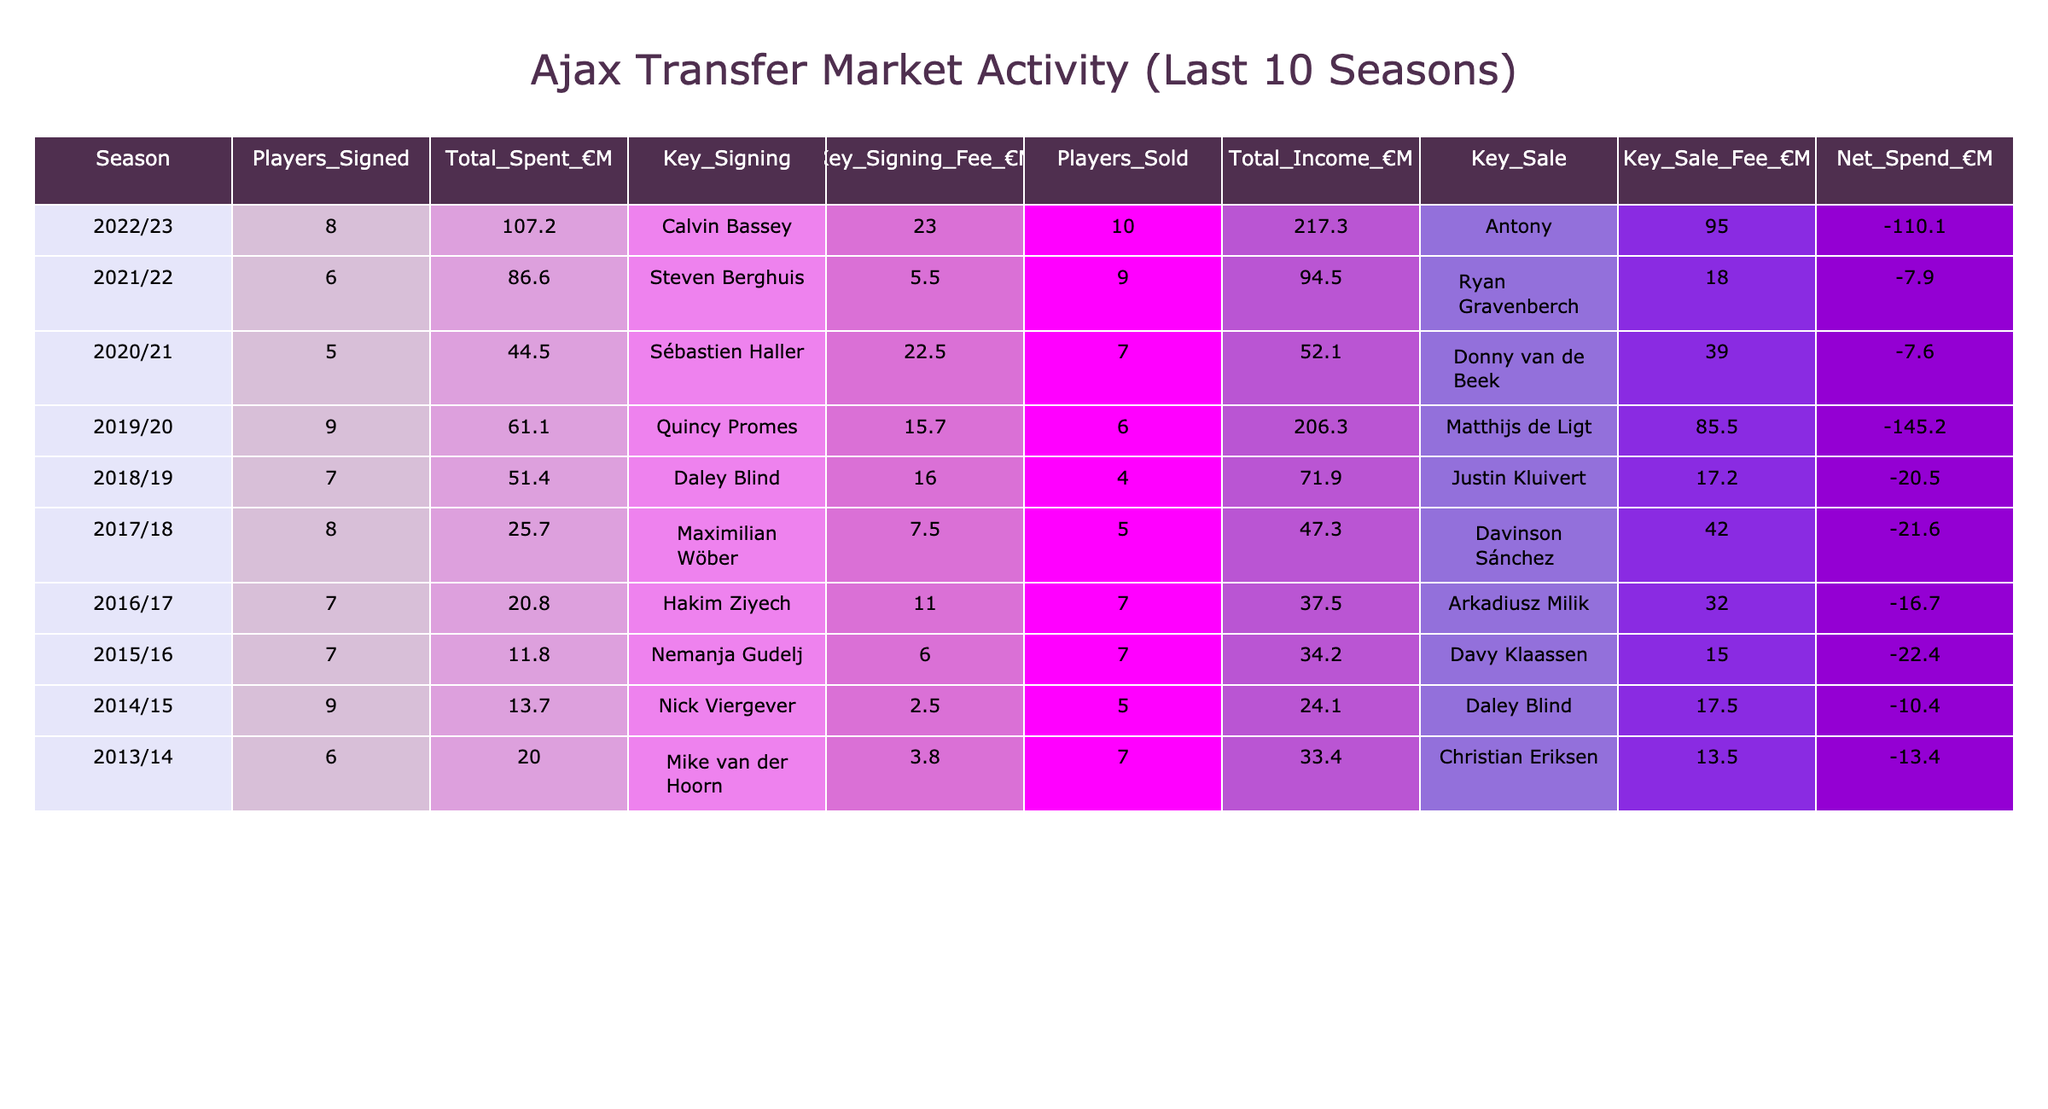What was Ajax's total spending in the 2022/23 season? In the 2022/23 season, the table shows that Ajax spent a total of €107.2 million.
Answer: 107.2 Who was the key signing for Ajax in the 2019/20 season? According to the table, the key signing for Ajax in the 2019/20 season was Quincy Promes.
Answer: Quincy Promes How many players did Ajax sell in the 2021/22 season? The table indicates that Ajax sold 9 players in the 2021/22 season.
Answer: 9 What was the net spend for Ajax during the 2018/19 season? The net spend for Ajax in the 2018/19 season was €-20.5 million, as shown in the table.
Answer: -20.5 During which season did Ajax have the highest total income from player sales? By reviewing the total income figures, it is clear that Ajax had the highest income of €217.3 million from player sales in the 2022/23 season.
Answer: 2022/23 What is the combined total spending for Ajax over the last three seasons (2020/21, 2021/22, and 2022/23)? The total spending for Ajax in these three seasons is calculated as follows: €44.5 million (2020/21) + €86.6 million (2021/22) + €107.2 million (2022/23) = €238.3 million.
Answer: 238.3 Was Ajax's total income from player sales higher in 2020/21 than in 2017/18? Looking at the total income figures, Ajax earned €52.1 million in 2020/21 and €47.3 million in 2017/18; thus, total income in 2020/21 was higher.
Answer: Yes What was the average key signing fee over the ten seasons? To find the average key signing fee, add the key signing fees: (23.0 + 5.5 + 22.5 + 15.7 + 16.0 + 7.5 + 11.0 + 6.0 + 2.5 + 3.8) = 113.5 million, then divide by 10 (the number of seasons). The average key signing fee is €11.35 million.
Answer: 11.35 In how many seasons did Ajax have a negative net spend? By reviewing the net spending values, Ajax had a negative net spend in six seasons (2022/23, 2019/20, 2018/19, 2017/18, 2016/17, and 2015/16).
Answer: 6 What was the key sale for Ajax in the 2014/15 season? The table indicates that the key sale for Ajax in the 2014/15 season was Daley Blind.
Answer: Daley Blind How much more did Ajax spend in the 2022/23 season compared to the 2014/15 season? The total spend for Ajax in 2022/23 was €107.2 million and in 2014/15 it was €13.7 million. The difference is calculated as €107.2 million - €13.7 million = €93.5 million.
Answer: 93.5 